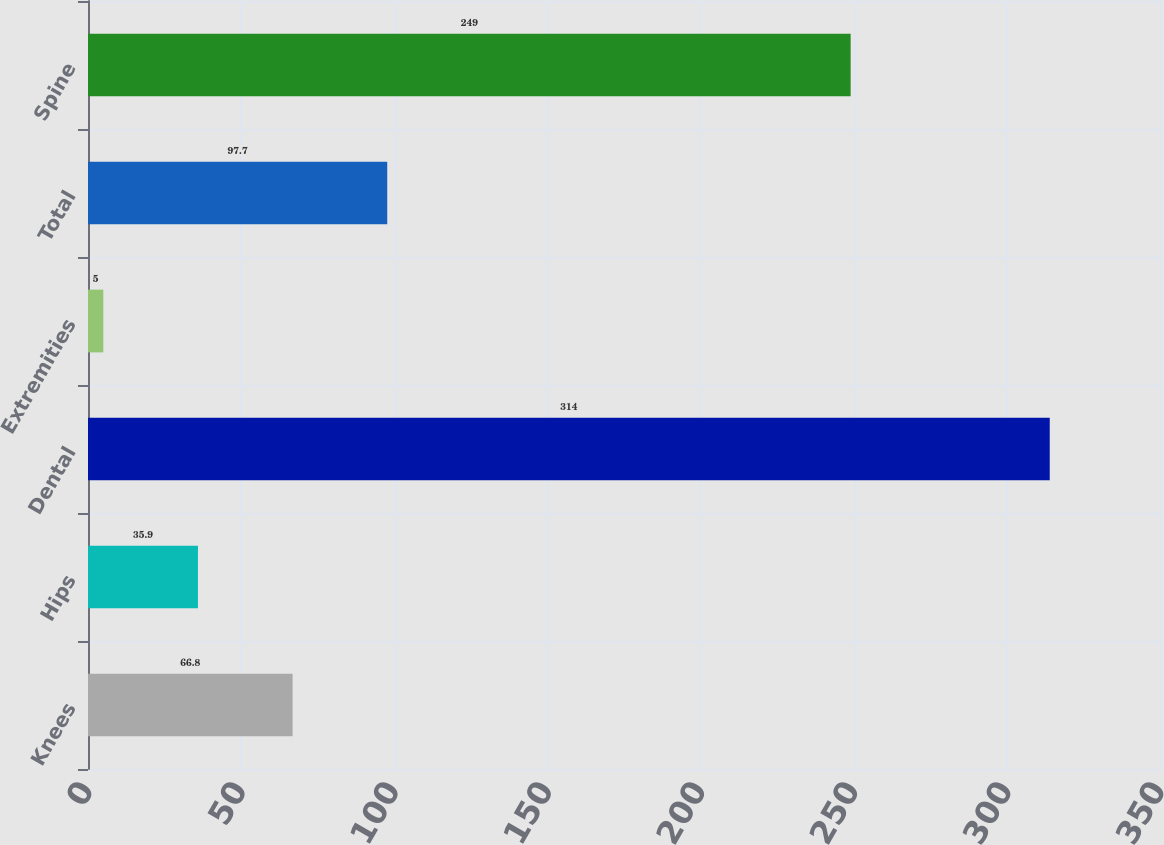Convert chart to OTSL. <chart><loc_0><loc_0><loc_500><loc_500><bar_chart><fcel>Knees<fcel>Hips<fcel>Dental<fcel>Extremities<fcel>Total<fcel>Spine<nl><fcel>66.8<fcel>35.9<fcel>314<fcel>5<fcel>97.7<fcel>249<nl></chart> 